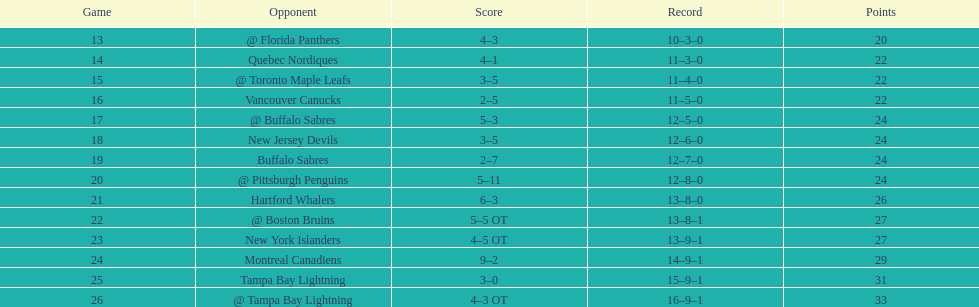The 1993-1994 flyers missed the playoffs again. how many consecutive seasons up until 93-94 did the flyers miss the playoffs? 5. 